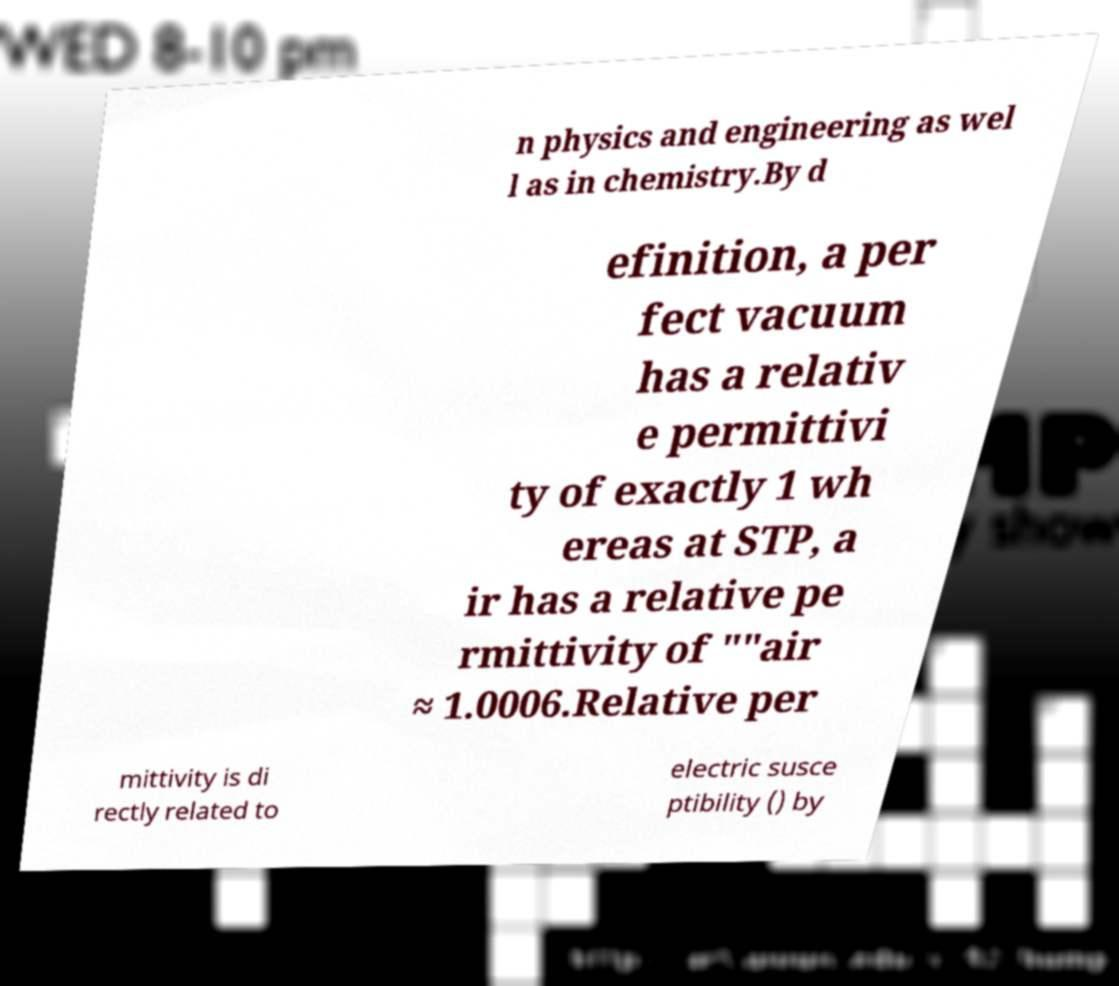Please read and relay the text visible in this image. What does it say? n physics and engineering as wel l as in chemistry.By d efinition, a per fect vacuum has a relativ e permittivi ty of exactly 1 wh ereas at STP, a ir has a relative pe rmittivity of ""air ≈ 1.0006.Relative per mittivity is di rectly related to electric susce ptibility () by 